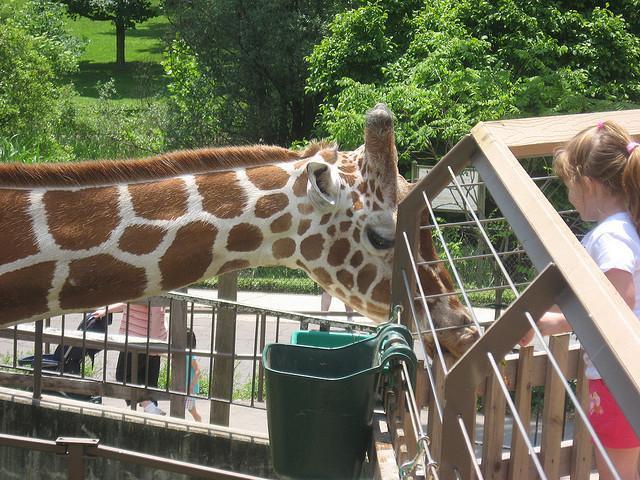How many children?
Give a very brief answer. 2. How many giraffes are there?
Give a very brief answer. 1. 